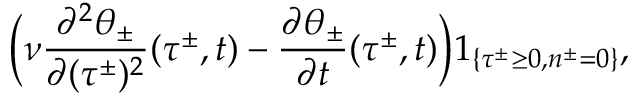Convert formula to latex. <formula><loc_0><loc_0><loc_500><loc_500>\left ( \nu \frac { \partial ^ { 2 } \theta _ { \pm } } { \partial ( \tau ^ { \pm } ) ^ { 2 } } ( \tau ^ { \pm } , t ) - \frac { \partial \theta _ { \pm } } { \partial t } ( \tau ^ { \pm } , t ) \right ) 1 _ { \{ \tau ^ { \pm } \geq 0 , n ^ { \pm } = 0 \} } ,</formula> 